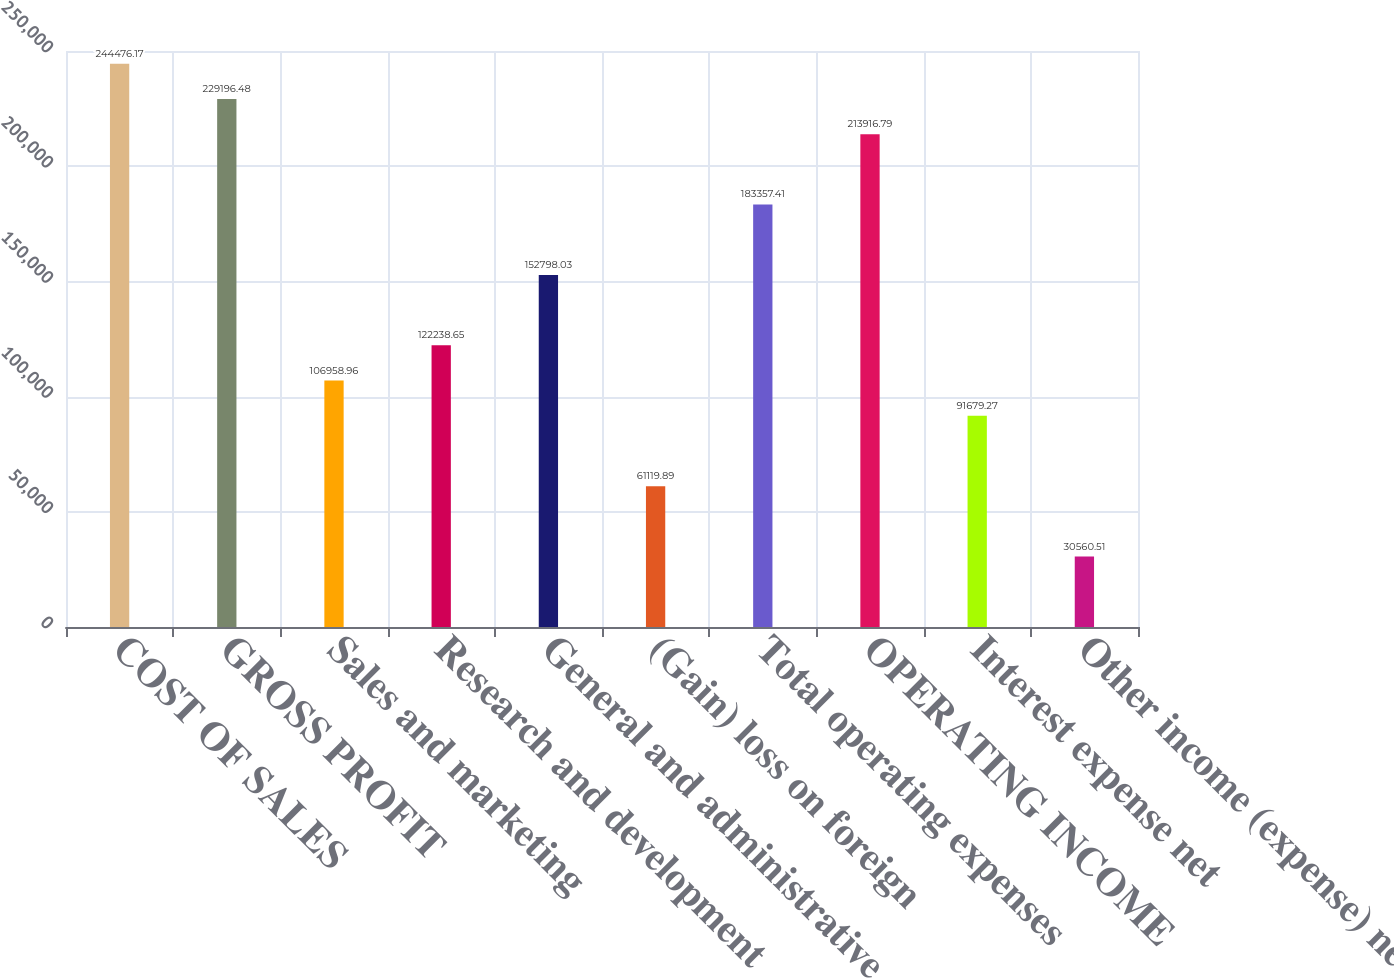<chart> <loc_0><loc_0><loc_500><loc_500><bar_chart><fcel>COST OF SALES<fcel>GROSS PROFIT<fcel>Sales and marketing<fcel>Research and development<fcel>General and administrative<fcel>(Gain) loss on foreign<fcel>Total operating expenses<fcel>OPERATING INCOME<fcel>Interest expense net<fcel>Other income (expense) net<nl><fcel>244476<fcel>229196<fcel>106959<fcel>122239<fcel>152798<fcel>61119.9<fcel>183357<fcel>213917<fcel>91679.3<fcel>30560.5<nl></chart> 